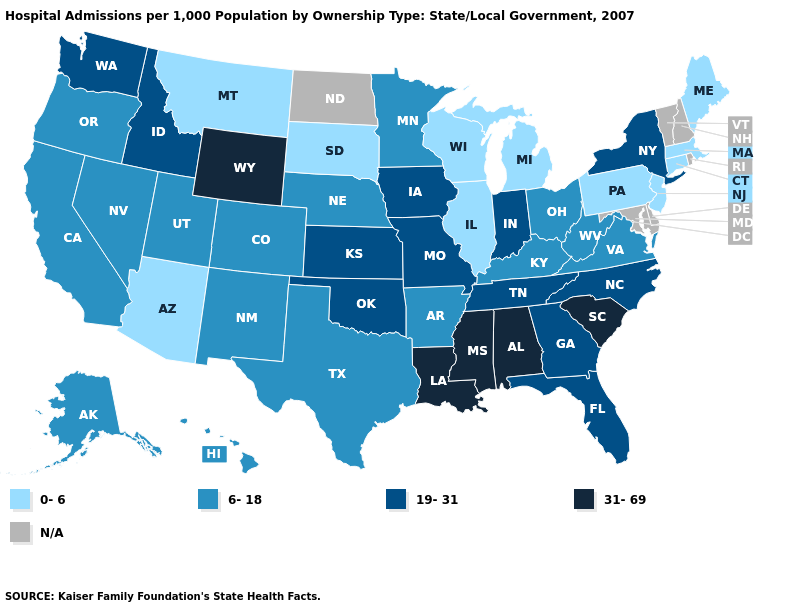Does Wyoming have the highest value in the West?
Answer briefly. Yes. What is the highest value in the West ?
Answer briefly. 31-69. Name the states that have a value in the range 31-69?
Keep it brief. Alabama, Louisiana, Mississippi, South Carolina, Wyoming. What is the highest value in the Northeast ?
Keep it brief. 19-31. What is the value of West Virginia?
Write a very short answer. 6-18. Which states have the lowest value in the USA?
Write a very short answer. Arizona, Connecticut, Illinois, Maine, Massachusetts, Michigan, Montana, New Jersey, Pennsylvania, South Dakota, Wisconsin. Which states hav the highest value in the MidWest?
Be succinct. Indiana, Iowa, Kansas, Missouri. Which states have the lowest value in the USA?
Short answer required. Arizona, Connecticut, Illinois, Maine, Massachusetts, Michigan, Montana, New Jersey, Pennsylvania, South Dakota, Wisconsin. What is the highest value in the West ?
Keep it brief. 31-69. What is the lowest value in states that border Nebraska?
Write a very short answer. 0-6. Name the states that have a value in the range 6-18?
Write a very short answer. Alaska, Arkansas, California, Colorado, Hawaii, Kentucky, Minnesota, Nebraska, Nevada, New Mexico, Ohio, Oregon, Texas, Utah, Virginia, West Virginia. What is the value of Washington?
Answer briefly. 19-31. Which states have the lowest value in the South?
Be succinct. Arkansas, Kentucky, Texas, Virginia, West Virginia. Which states have the lowest value in the USA?
Be succinct. Arizona, Connecticut, Illinois, Maine, Massachusetts, Michigan, Montana, New Jersey, Pennsylvania, South Dakota, Wisconsin. What is the highest value in states that border Oklahoma?
Write a very short answer. 19-31. 